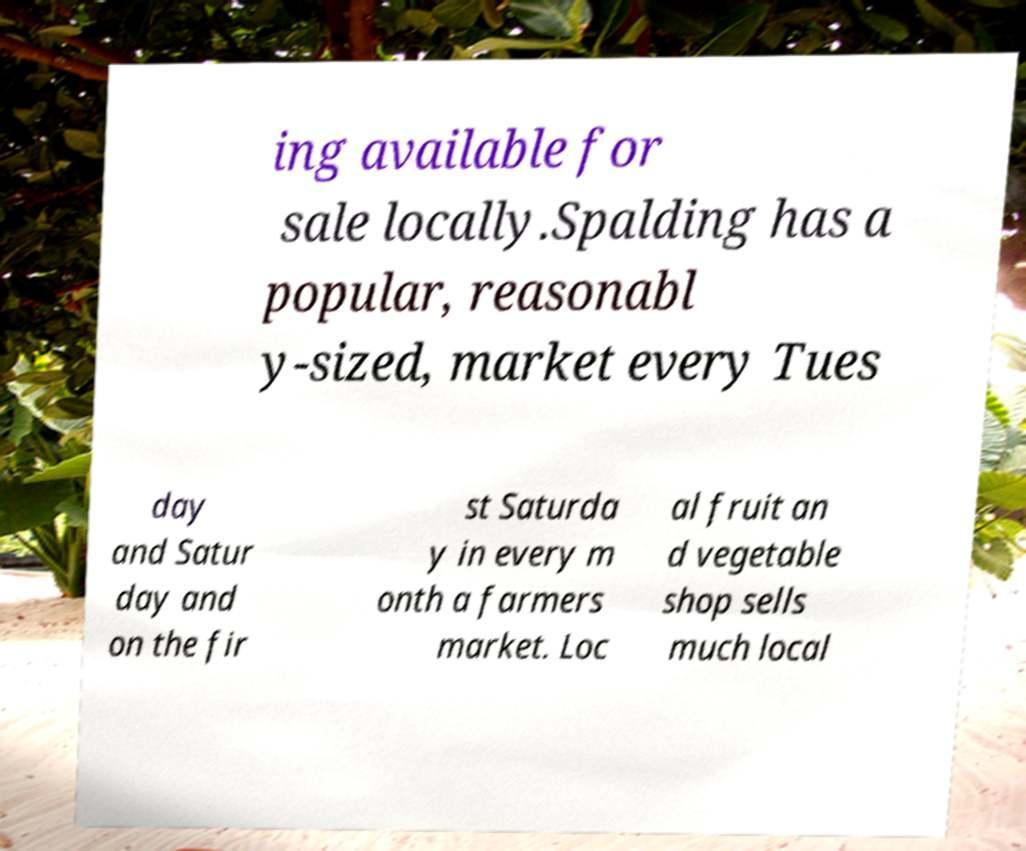There's text embedded in this image that I need extracted. Can you transcribe it verbatim? ing available for sale locally.Spalding has a popular, reasonabl y-sized, market every Tues day and Satur day and on the fir st Saturda y in every m onth a farmers market. Loc al fruit an d vegetable shop sells much local 